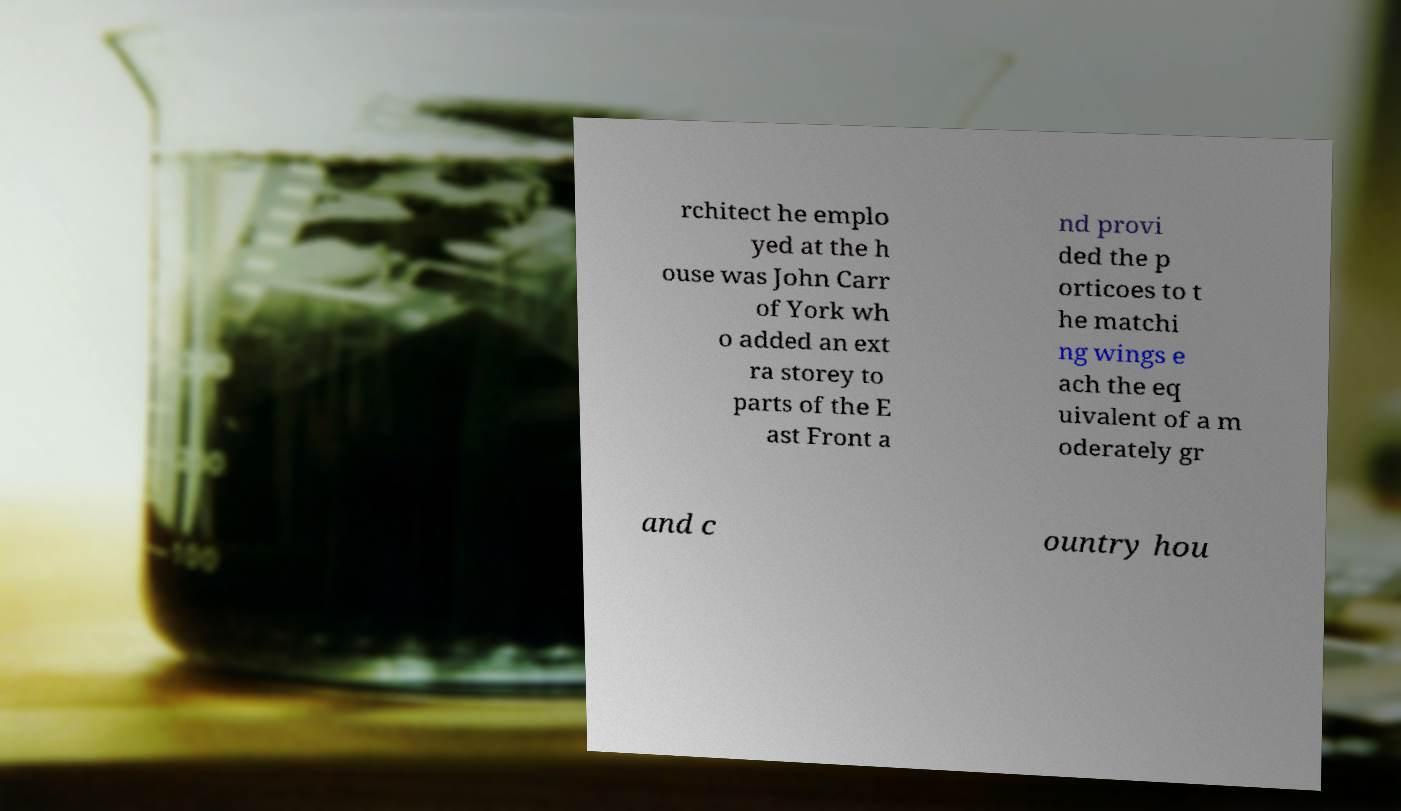Please identify and transcribe the text found in this image. rchitect he emplo yed at the h ouse was John Carr of York wh o added an ext ra storey to parts of the E ast Front a nd provi ded the p orticoes to t he matchi ng wings e ach the eq uivalent of a m oderately gr and c ountry hou 